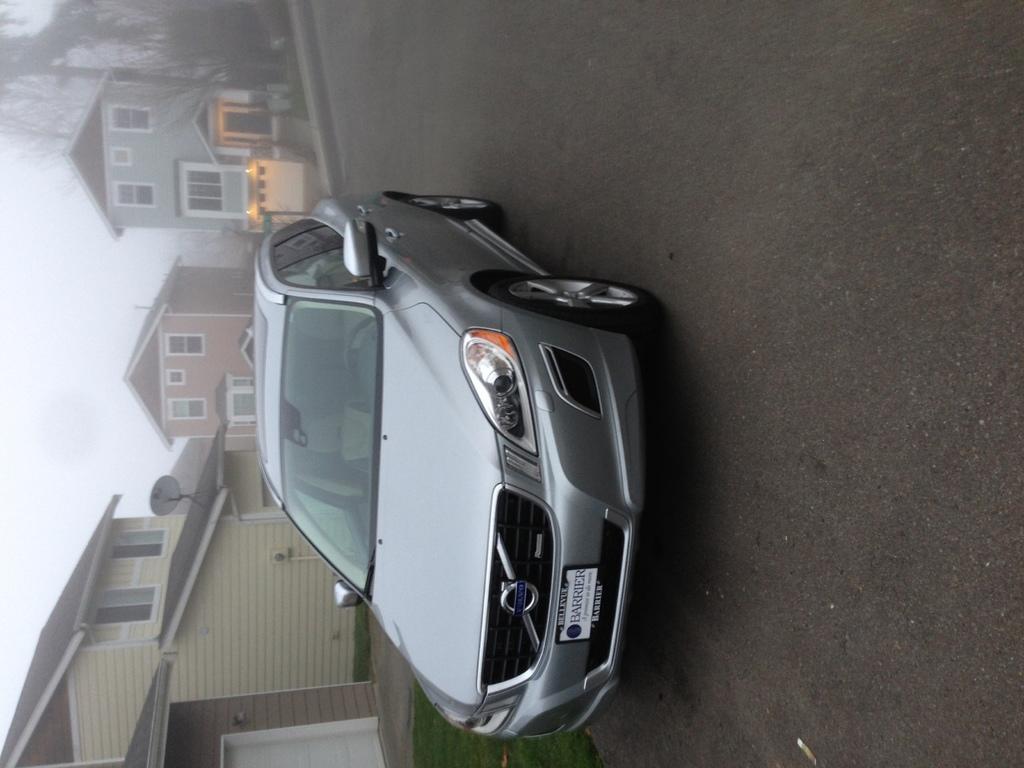Describe this image in one or two sentences. In this image there is a car on the road, and in the background there is grass, buildings, antenna, lights, trees, sky. 